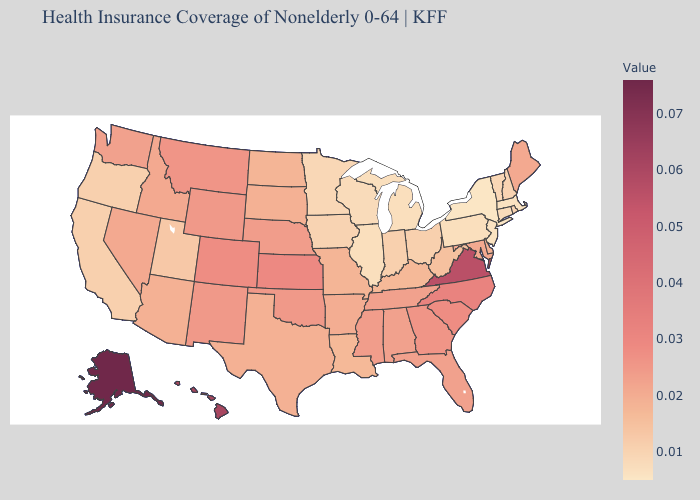Does the map have missing data?
Write a very short answer. No. Does Wisconsin have the highest value in the USA?
Write a very short answer. No. Does the map have missing data?
Write a very short answer. No. Which states hav the highest value in the South?
Give a very brief answer. Virginia. Is the legend a continuous bar?
Short answer required. Yes. Among the states that border Kentucky , does Indiana have the lowest value?
Short answer required. No. 